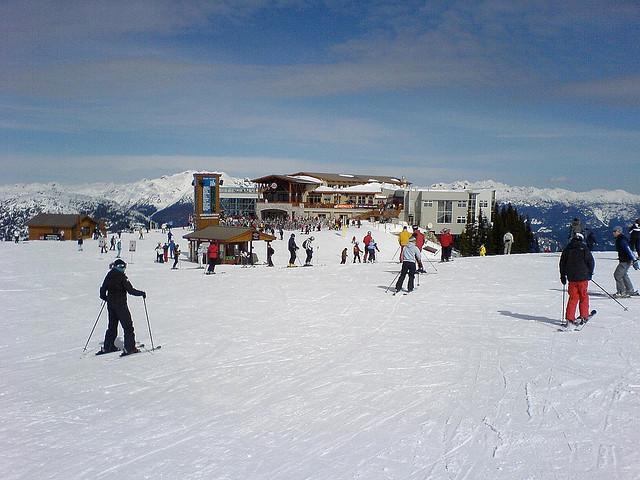Is it winter?
Give a very brief answer. Yes. Is "alpine" an appropriate adjective for the building in this image?
Short answer required. Yes. What is the person in red pants on?
Answer briefly. Skis. What are they skiing on?
Answer briefly. Snow. 